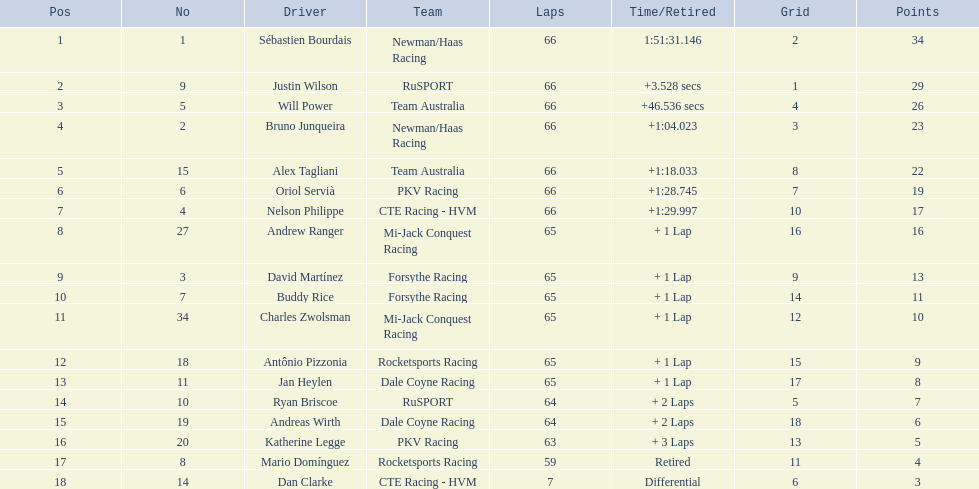Who are all of the 2006 gran premio telmex drivers? Sébastien Bourdais, Justin Wilson, Will Power, Bruno Junqueira, Alex Tagliani, Oriol Servià, Nelson Philippe, Andrew Ranger, David Martínez, Buddy Rice, Charles Zwolsman, Antônio Pizzonia, Jan Heylen, Ryan Briscoe, Andreas Wirth, Katherine Legge, Mario Domínguez, Dan Clarke. How many laps did they finish? 66, 66, 66, 66, 66, 66, 66, 65, 65, 65, 65, 65, 65, 64, 64, 63, 59, 7. What about just oriol servia and katherine legge? 66, 63. And which of those two drivers finished more laps? Oriol Servià. 